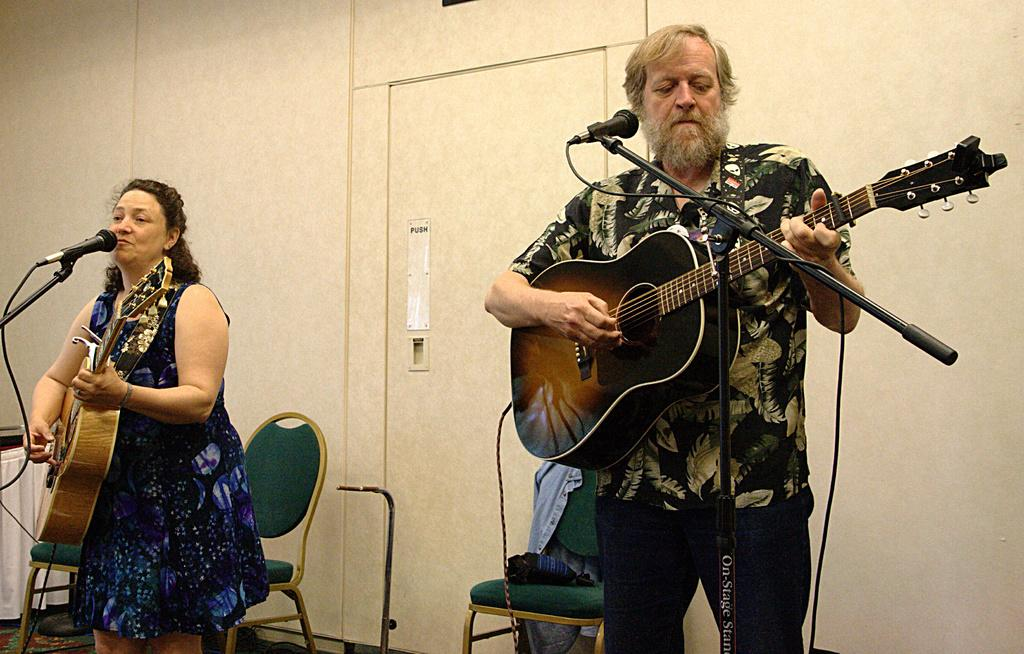How many people are in the image? There are two persons in the image. What are the two persons doing? One person is playing a guitar, and the other person is singing a song. What can be seen in the background of the image? There is a white color wall in the background of the image. What type of quilt is being used as a disguise by the spy in the image? There is no spy or quilt present in the image. What effect does the music have on the audience in the image? There is no audience present in the image, so it's not possible to determine the effect of the music on them. 